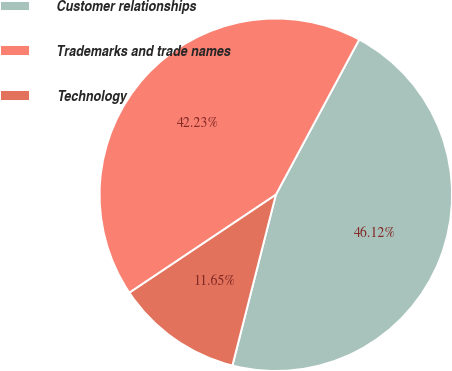Convert chart. <chart><loc_0><loc_0><loc_500><loc_500><pie_chart><fcel>Customer relationships<fcel>Trademarks and trade names<fcel>Technology<nl><fcel>46.12%<fcel>42.23%<fcel>11.65%<nl></chart> 